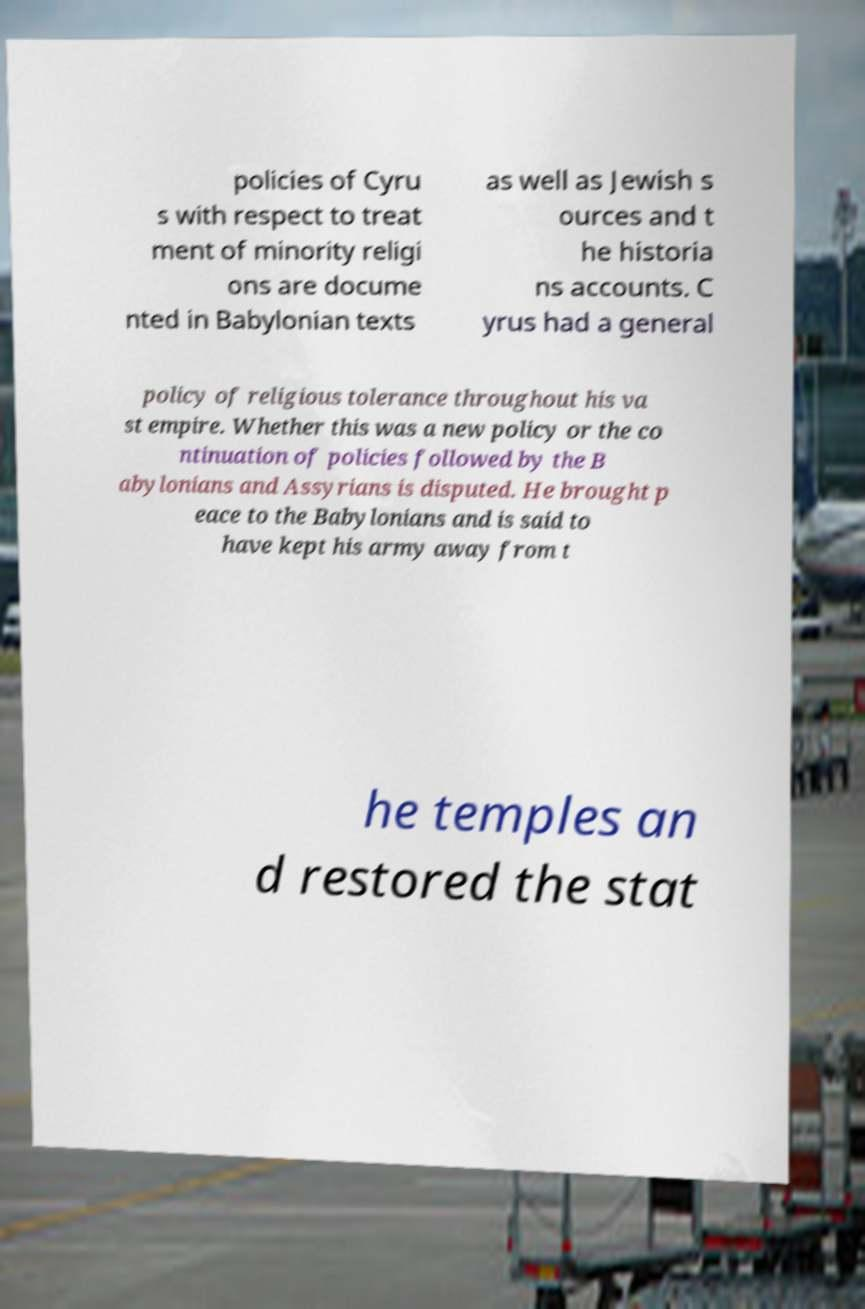Please identify and transcribe the text found in this image. policies of Cyru s with respect to treat ment of minority religi ons are docume nted in Babylonian texts as well as Jewish s ources and t he historia ns accounts. C yrus had a general policy of religious tolerance throughout his va st empire. Whether this was a new policy or the co ntinuation of policies followed by the B abylonians and Assyrians is disputed. He brought p eace to the Babylonians and is said to have kept his army away from t he temples an d restored the stat 